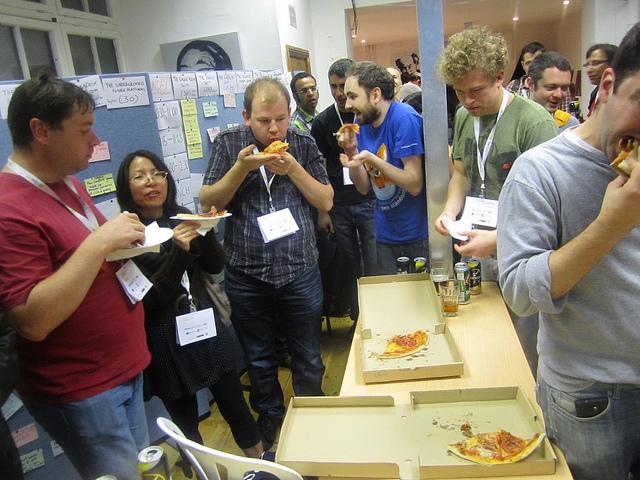What is everyone wearing around their neck?
Give a very brief answer. Lanyards. What are the people eating?
Keep it brief. Pizza. Is there a whole pizza left?
Give a very brief answer. No. Are there a lot of wires on the table?
Short answer required. No. 